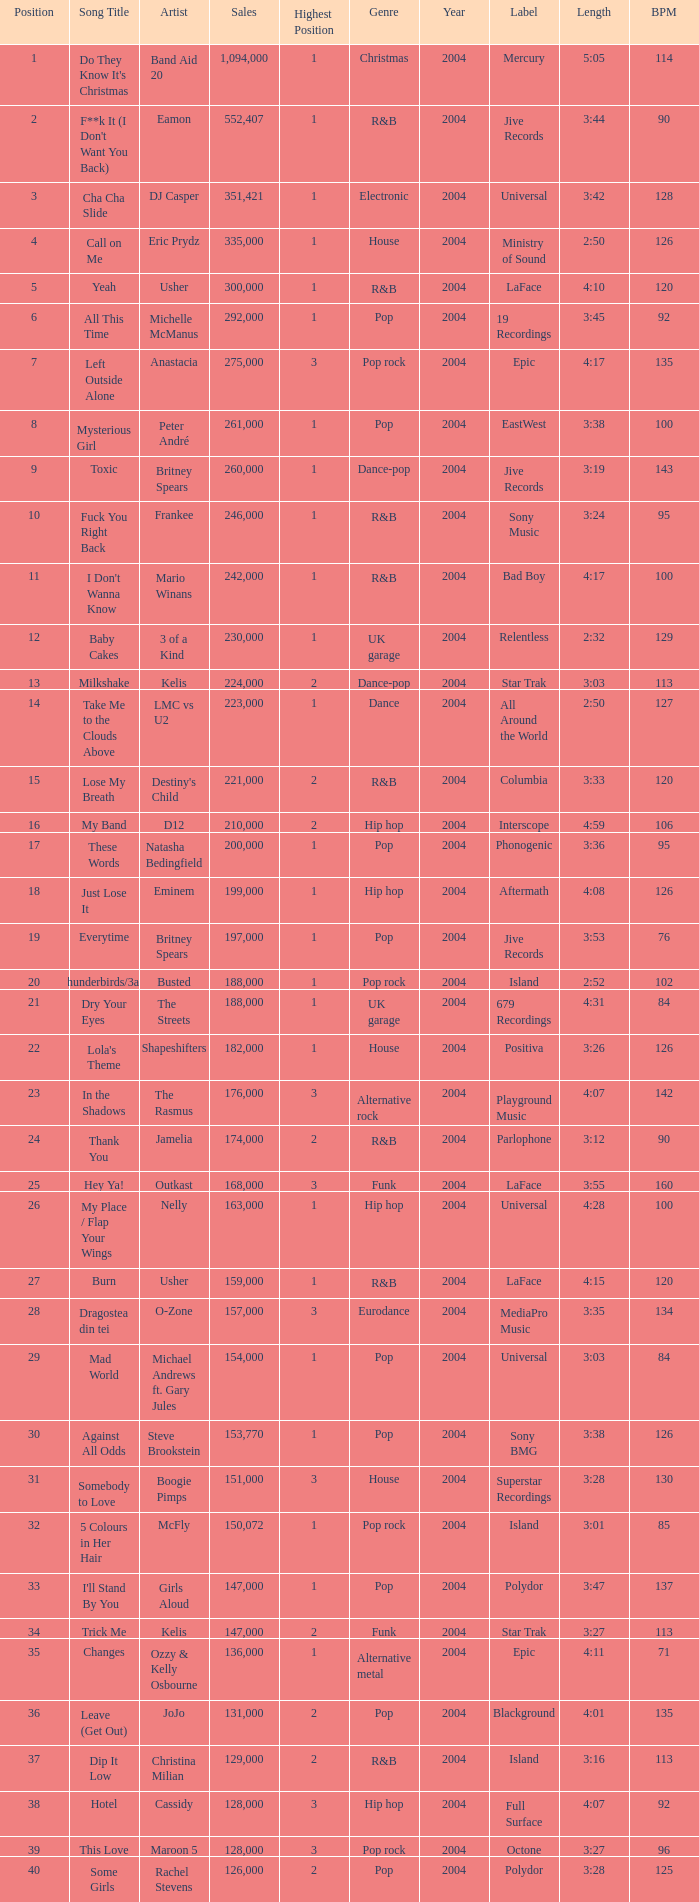What were the sales for Dj Casper when he was in a position lower than 13? 351421.0. 